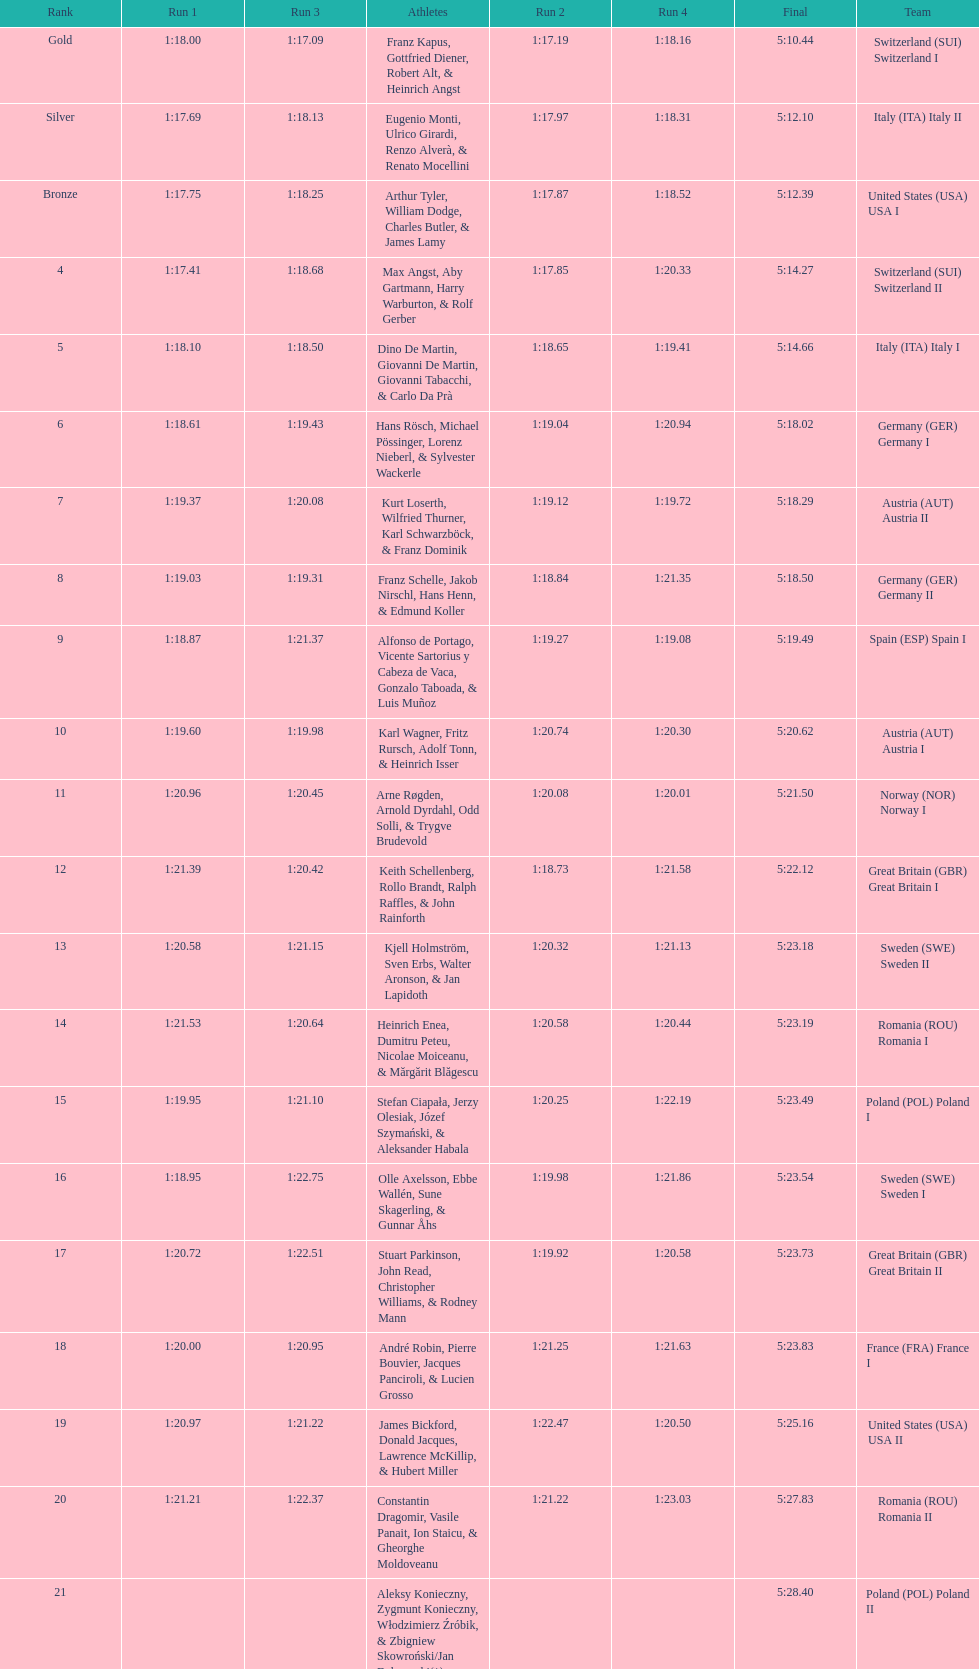Name a country that had 4 consecutive runs under 1:19. Switzerland. 